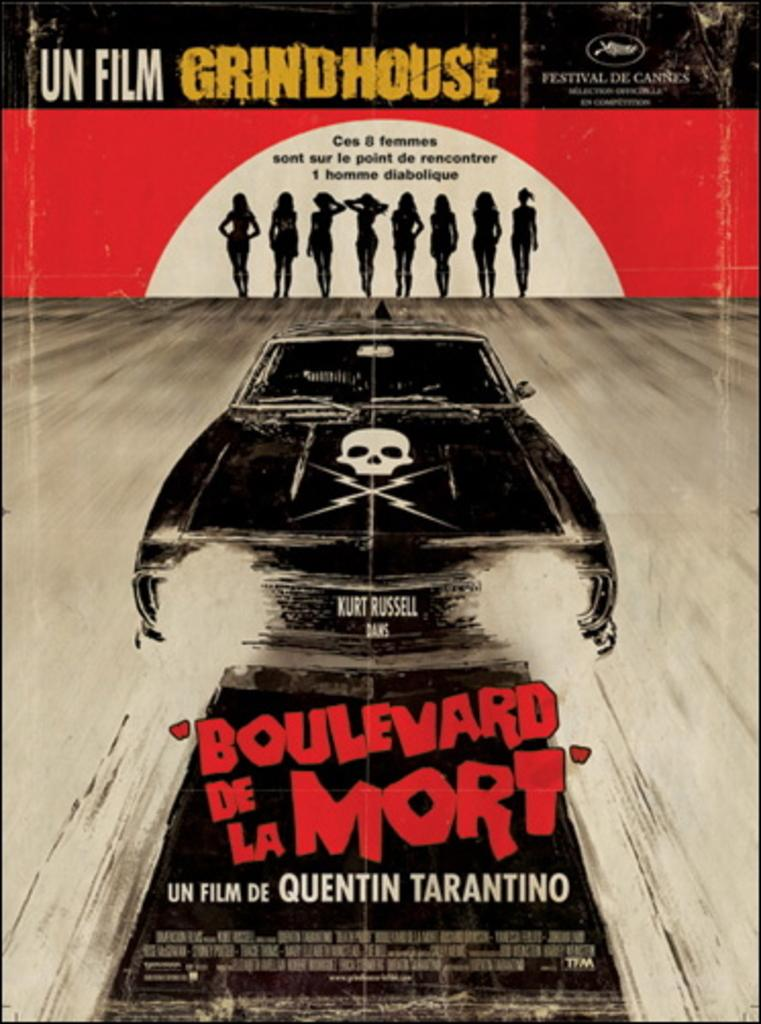<image>
Offer a succinct explanation of the picture presented. a poster for a movie from Grindhouse by Tarantino 